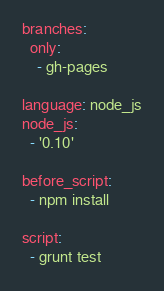<code> <loc_0><loc_0><loc_500><loc_500><_YAML_>branches:
  only:
    - gh-pages
    
language: node_js
node_js:
  - '0.10'

before_script:
  - npm install

script:
  - grunt test
</code> 